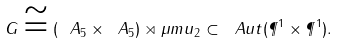<formula> <loc_0><loc_0><loc_500><loc_500>G \cong \left ( \ A _ { 5 } \times \ A _ { 5 } \right ) \rtimes \mu m u _ { 2 } \subset \ A u t ( \P ^ { 1 } \times \P ^ { 1 } ) .</formula> 